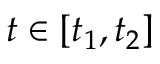Convert formula to latex. <formula><loc_0><loc_0><loc_500><loc_500>t \in [ t _ { 1 } , t _ { 2 } ]</formula> 